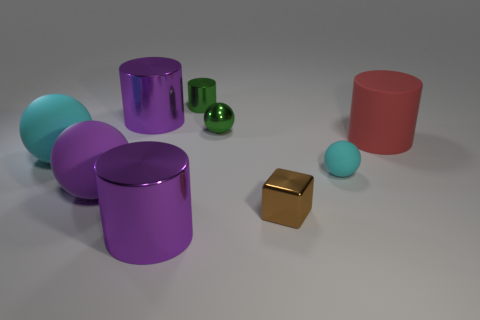Add 6 small cyan balls. How many small cyan balls exist? 7 Subtract all cyan balls. How many balls are left? 2 Subtract all small cyan balls. How many balls are left? 3 Subtract 1 green spheres. How many objects are left? 8 Subtract all cubes. How many objects are left? 8 Subtract 1 blocks. How many blocks are left? 0 Subtract all red cylinders. Subtract all cyan cubes. How many cylinders are left? 3 Subtract all cyan blocks. How many purple cylinders are left? 2 Subtract all large cyan rubber things. Subtract all small green shiny things. How many objects are left? 6 Add 5 small cyan objects. How many small cyan objects are left? 6 